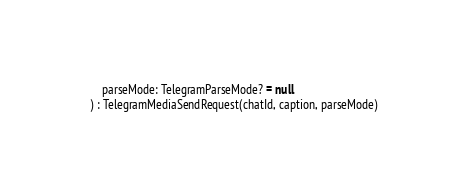Convert code to text. <code><loc_0><loc_0><loc_500><loc_500><_Kotlin_>
    parseMode: TelegramParseMode? = null
) : TelegramMediaSendRequest(chatId, caption, parseMode)</code> 